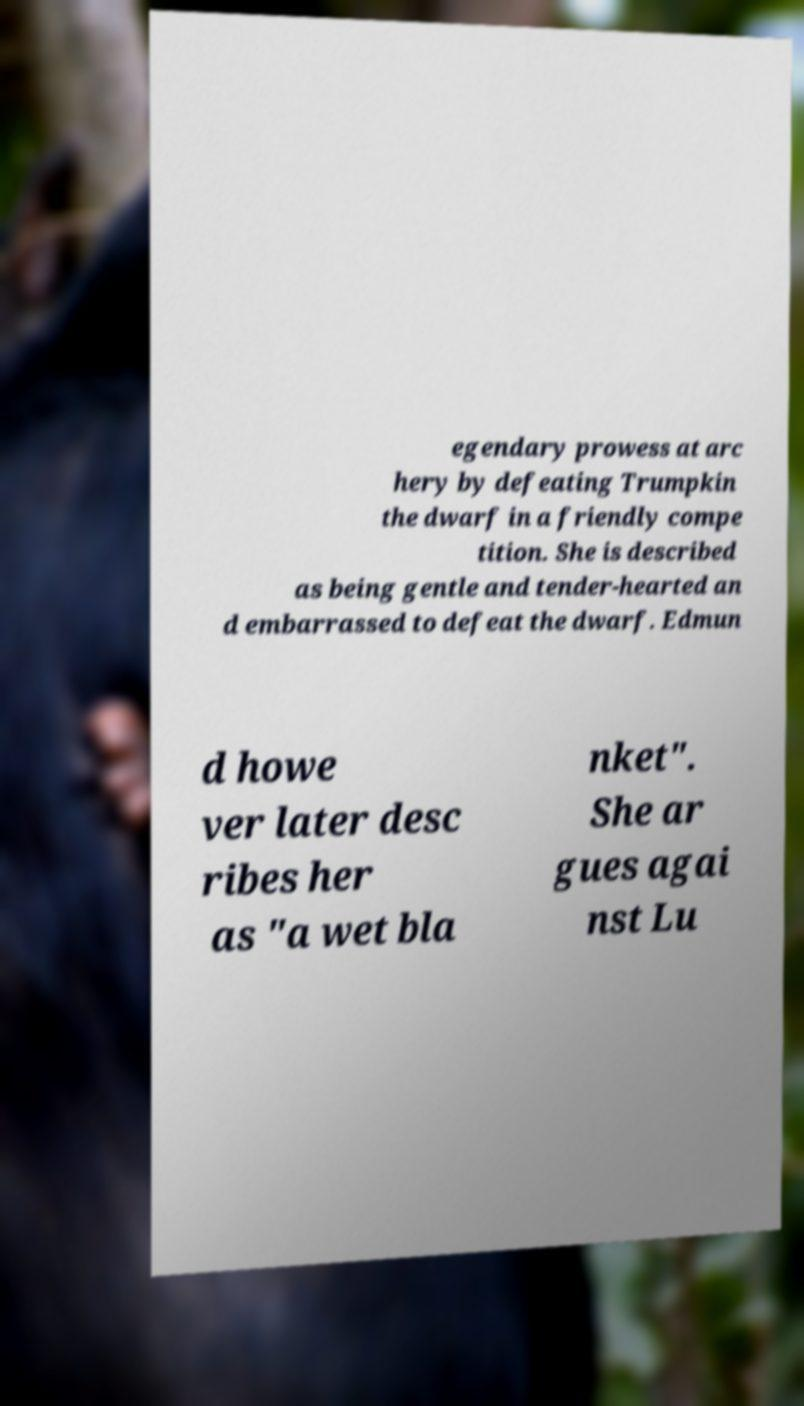Please identify and transcribe the text found in this image. egendary prowess at arc hery by defeating Trumpkin the dwarf in a friendly compe tition. She is described as being gentle and tender-hearted an d embarrassed to defeat the dwarf. Edmun d howe ver later desc ribes her as "a wet bla nket". She ar gues agai nst Lu 